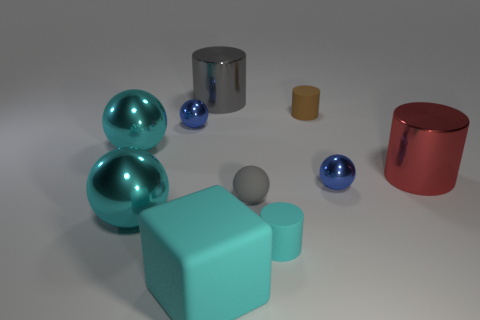How many objects are there in total within the image? There are a total of nine objects visible in the image, consisting of various geometric shapes and colors. 